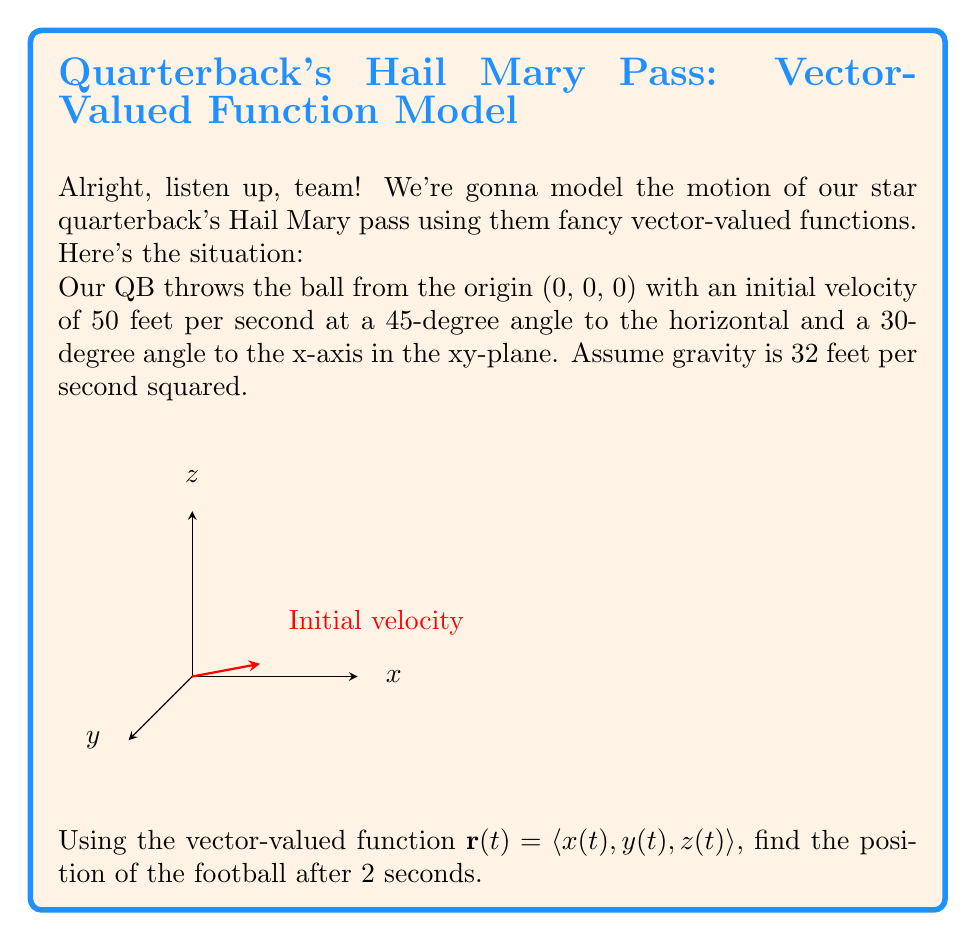Show me your answer to this math problem. Alright, let's break this down step-by-step:

1) First, we need to set up our initial velocity vector. The magnitude is 50 ft/s, and we need to split it into x, y, and z components:

   $v_x = 50 \cos(45°) \cos(30°) = 50 \cdot \frac{\sqrt{2}}{2} \cdot \frac{\sqrt{3}}{2} = 25\sqrt{3}$
   $v_y = 50 \cos(45°) \sin(30°) = 50 \cdot \frac{\sqrt{2}}{2} \cdot \frac{1}{2} = 25\sqrt{2}/2$
   $v_z = 50 \sin(45°) = 50 \cdot \frac{\sqrt{2}}{2} = 25\sqrt{2}$

2) Now, we can set up our vector-valued function:

   $$\mathbf{r}(t) = \langle x(t), y(t), z(t) \rangle = \langle v_x t, v_y t, v_z t - \frac{1}{2}gt^2 \rangle$$

   Where $g = 32$ ft/s².

3) Substituting our values:

   $$\mathbf{r}(t) = \langle 25\sqrt{3}t, \frac{25\sqrt{2}}{2}t, 25\sqrt{2}t - 16t^2 \rangle$$

4) Now, we need to find the position after 2 seconds. Let's substitute $t = 2$:

   $$\mathbf{r}(2) = \langle 25\sqrt{3}(2), \frac{25\sqrt{2}}{2}(2), 25\sqrt{2}(2) - 16(2)^2 \rangle$$

5) Let's calculate each component:

   $x(2) = 50\sqrt{3} \approx 86.60$ ft
   $y(2) = 25\sqrt{2} \approx 35.36$ ft
   $z(2) = 50\sqrt{2} - 64 \approx 6.57$ ft

6) Therefore, the position of the football after 2 seconds is:

   $$\mathbf{r}(2) = \langle 50\sqrt{3}, 25\sqrt{2}, 50\sqrt{2} - 64 \rangle$$
Answer: $\langle 50\sqrt{3}, 25\sqrt{2}, 50\sqrt{2} - 64 \rangle$ ft 